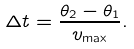Convert formula to latex. <formula><loc_0><loc_0><loc_500><loc_500>\Delta t = \frac { \theta _ { 2 } - \theta _ { 1 } } { v _ { \max } } .</formula> 